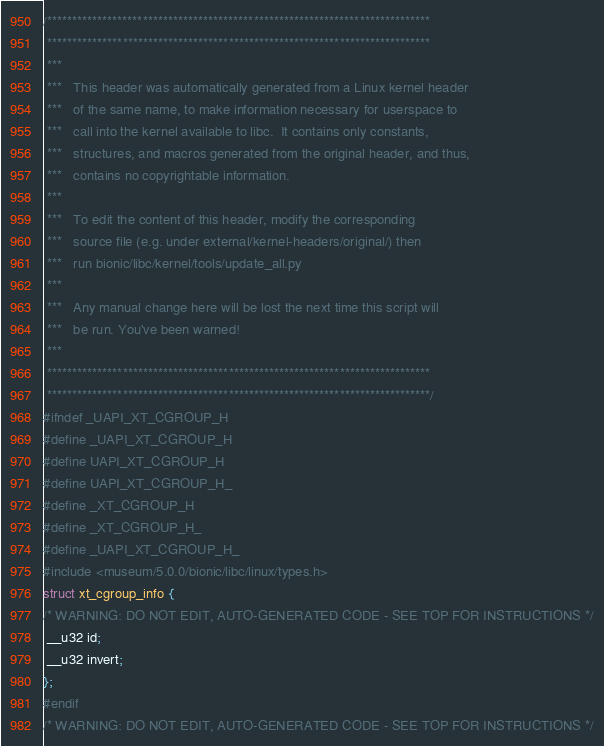<code> <loc_0><loc_0><loc_500><loc_500><_C_>/****************************************************************************
 ****************************************************************************
 ***
 ***   This header was automatically generated from a Linux kernel header
 ***   of the same name, to make information necessary for userspace to
 ***   call into the kernel available to libc.  It contains only constants,
 ***   structures, and macros generated from the original header, and thus,
 ***   contains no copyrightable information.
 ***
 ***   To edit the content of this header, modify the corresponding
 ***   source file (e.g. under external/kernel-headers/original/) then
 ***   run bionic/libc/kernel/tools/update_all.py
 ***
 ***   Any manual change here will be lost the next time this script will
 ***   be run. You've been warned!
 ***
 ****************************************************************************
 ****************************************************************************/
#ifndef _UAPI_XT_CGROUP_H
#define _UAPI_XT_CGROUP_H
#define UAPI_XT_CGROUP_H
#define UAPI_XT_CGROUP_H_
#define _XT_CGROUP_H
#define _XT_CGROUP_H_
#define _UAPI_XT_CGROUP_H_
#include <museum/5.0.0/bionic/libc/linux/types.h>
struct xt_cgroup_info {
/* WARNING: DO NOT EDIT, AUTO-GENERATED CODE - SEE TOP FOR INSTRUCTIONS */
 __u32 id;
 __u32 invert;
};
#endif
/* WARNING: DO NOT EDIT, AUTO-GENERATED CODE - SEE TOP FOR INSTRUCTIONS */
</code> 